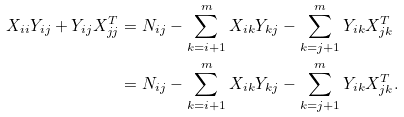Convert formula to latex. <formula><loc_0><loc_0><loc_500><loc_500>X _ { i i } Y _ { i j } + Y _ { i j } X _ { j j } ^ { T } & = N _ { i j } - \sum _ { k = i + 1 } ^ { m } X _ { i k } Y _ { k j } - \sum _ { k = j + 1 } ^ { m } Y _ { i k } X _ { j k } ^ { T } \\ & = N _ { i j } - \sum _ { k = i + 1 } ^ { m } X _ { i k } Y _ { k j } - \sum _ { k = j + 1 } ^ { m } Y _ { i k } X _ { j k } ^ { T } . \\</formula> 